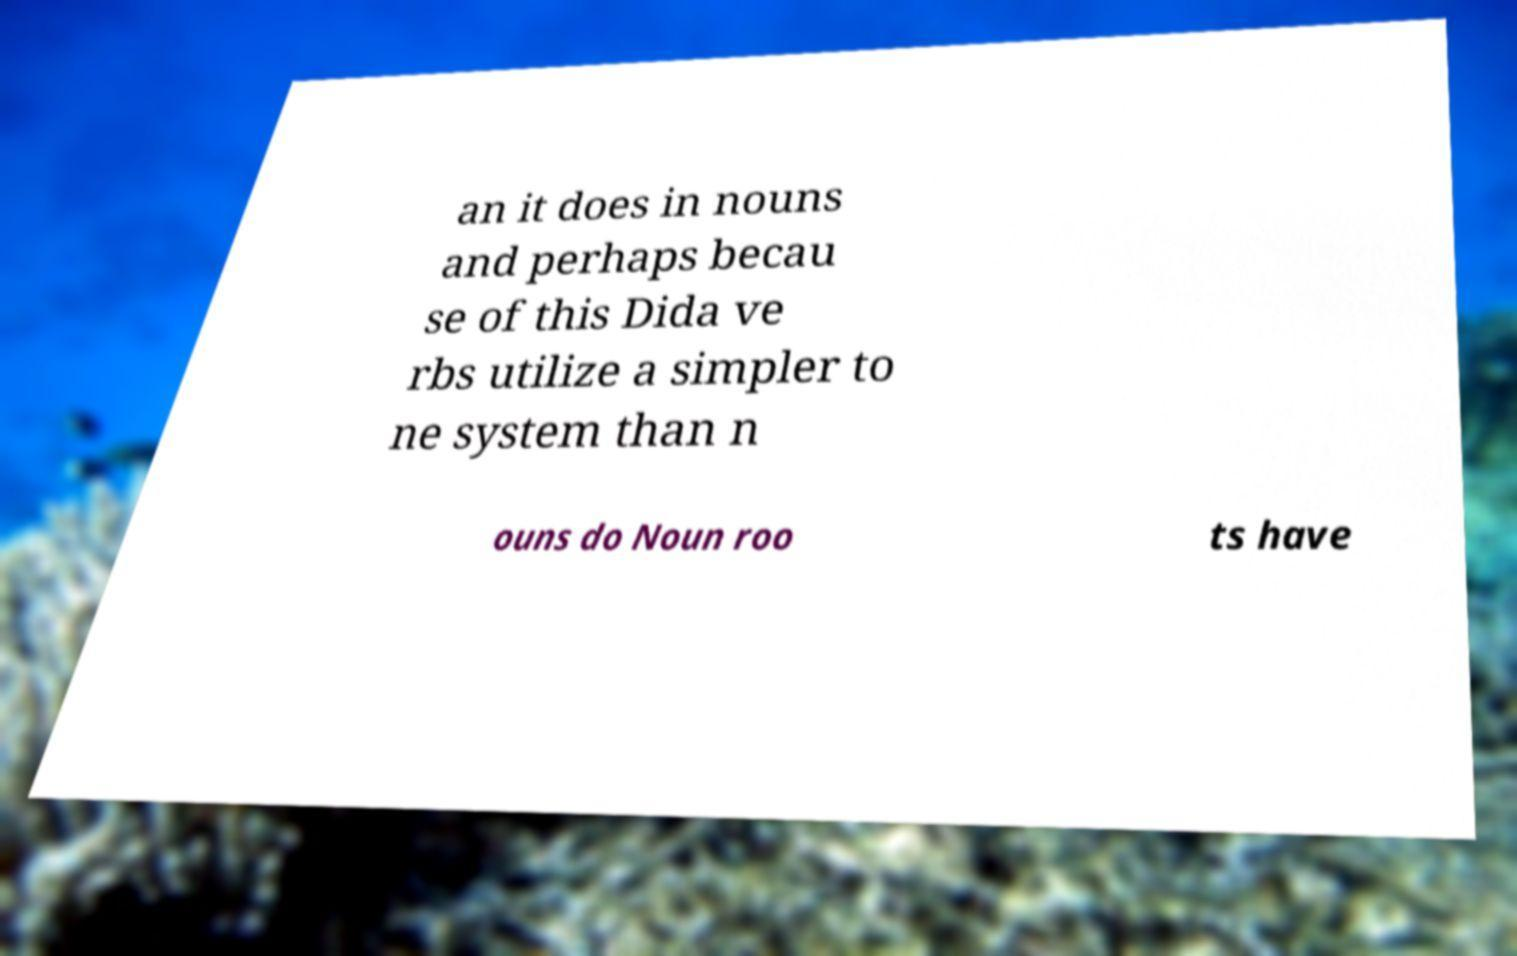I need the written content from this picture converted into text. Can you do that? an it does in nouns and perhaps becau se of this Dida ve rbs utilize a simpler to ne system than n ouns do Noun roo ts have 